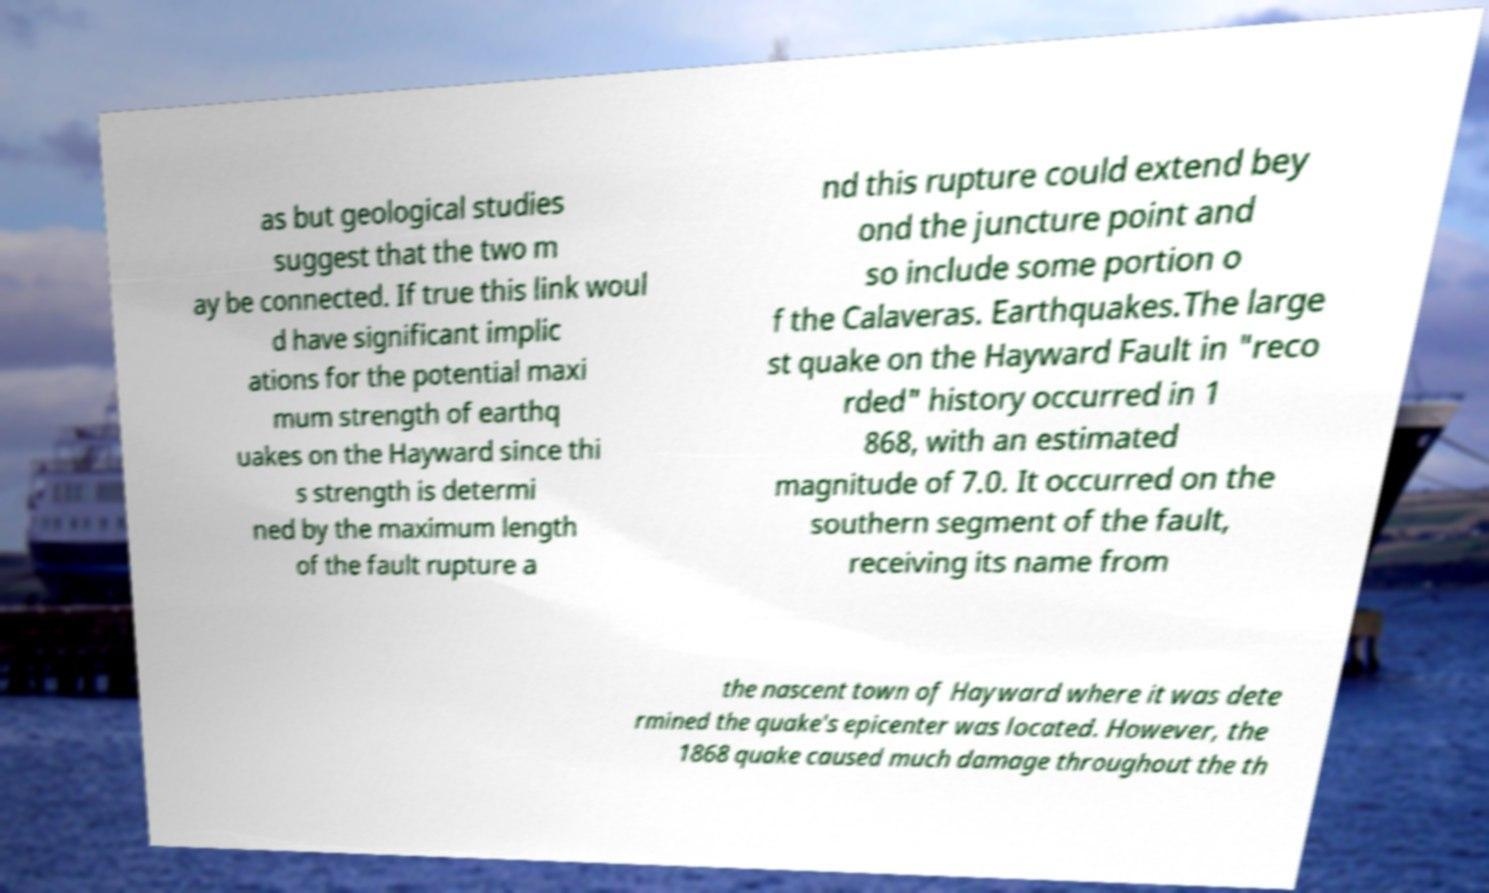Could you extract and type out the text from this image? as but geological studies suggest that the two m ay be connected. If true this link woul d have significant implic ations for the potential maxi mum strength of earthq uakes on the Hayward since thi s strength is determi ned by the maximum length of the fault rupture a nd this rupture could extend bey ond the juncture point and so include some portion o f the Calaveras. Earthquakes.The large st quake on the Hayward Fault in "reco rded" history occurred in 1 868, with an estimated magnitude of 7.0. It occurred on the southern segment of the fault, receiving its name from the nascent town of Hayward where it was dete rmined the quake's epicenter was located. However, the 1868 quake caused much damage throughout the th 